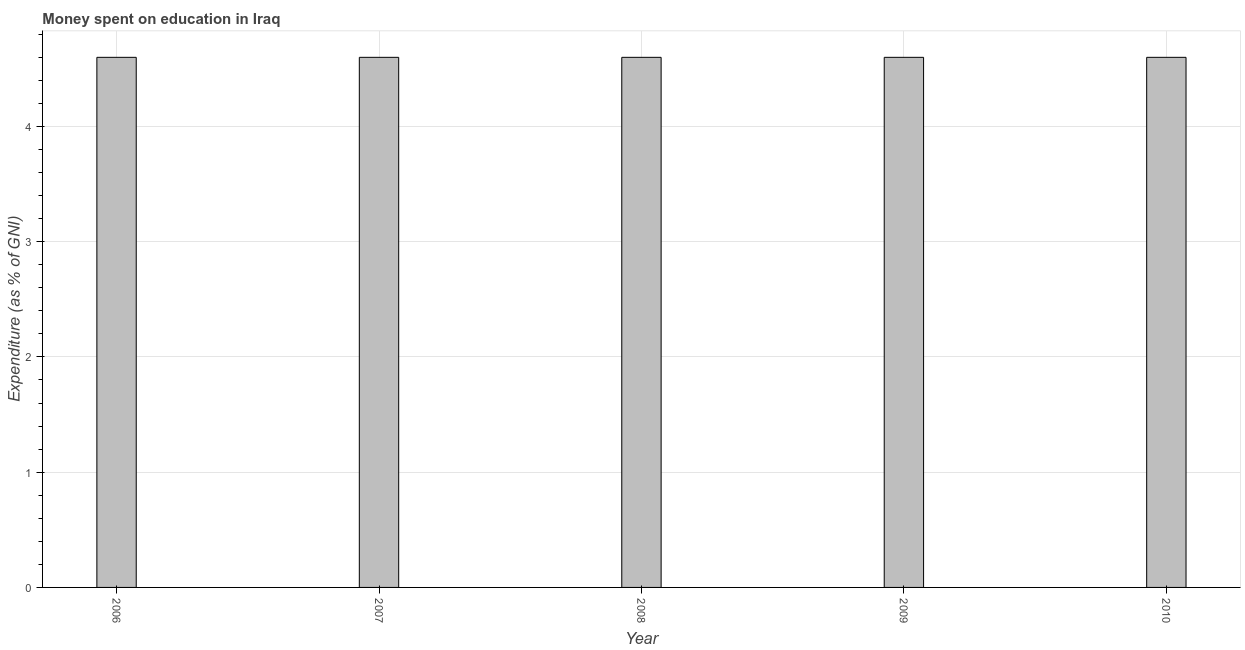Does the graph contain any zero values?
Offer a terse response. No. What is the title of the graph?
Make the answer very short. Money spent on education in Iraq. What is the label or title of the X-axis?
Your response must be concise. Year. What is the label or title of the Y-axis?
Make the answer very short. Expenditure (as % of GNI). What is the expenditure on education in 2006?
Offer a very short reply. 4.6. Across all years, what is the maximum expenditure on education?
Provide a short and direct response. 4.6. Across all years, what is the minimum expenditure on education?
Provide a short and direct response. 4.6. In which year was the expenditure on education minimum?
Offer a very short reply. 2006. What is the difference between the expenditure on education in 2008 and 2010?
Your response must be concise. 0. What is the median expenditure on education?
Keep it short and to the point. 4.6. Do a majority of the years between 2006 and 2010 (inclusive) have expenditure on education greater than 1.6 %?
Make the answer very short. Yes. Is the expenditure on education in 2007 less than that in 2009?
Keep it short and to the point. No. Is the difference between the expenditure on education in 2007 and 2008 greater than the difference between any two years?
Your answer should be compact. Yes. What is the difference between the highest and the second highest expenditure on education?
Provide a short and direct response. 0. In how many years, is the expenditure on education greater than the average expenditure on education taken over all years?
Make the answer very short. 0. How many bars are there?
Provide a short and direct response. 5. Are all the bars in the graph horizontal?
Give a very brief answer. No. How many years are there in the graph?
Give a very brief answer. 5. What is the Expenditure (as % of GNI) of 2008?
Make the answer very short. 4.6. What is the Expenditure (as % of GNI) in 2009?
Offer a terse response. 4.6. What is the difference between the Expenditure (as % of GNI) in 2006 and 2010?
Give a very brief answer. 0. What is the difference between the Expenditure (as % of GNI) in 2007 and 2009?
Ensure brevity in your answer.  0. What is the difference between the Expenditure (as % of GNI) in 2007 and 2010?
Your answer should be compact. 0. What is the difference between the Expenditure (as % of GNI) in 2008 and 2009?
Your answer should be very brief. 0. What is the ratio of the Expenditure (as % of GNI) in 2006 to that in 2009?
Provide a short and direct response. 1. What is the ratio of the Expenditure (as % of GNI) in 2007 to that in 2008?
Make the answer very short. 1. What is the ratio of the Expenditure (as % of GNI) in 2008 to that in 2009?
Keep it short and to the point. 1. 